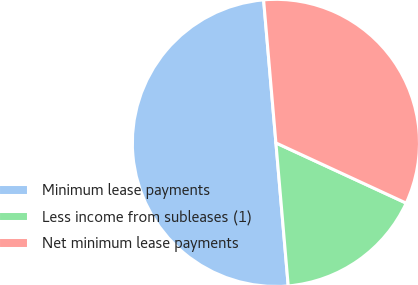Convert chart to OTSL. <chart><loc_0><loc_0><loc_500><loc_500><pie_chart><fcel>Minimum lease payments<fcel>Less income from subleases (1)<fcel>Net minimum lease payments<nl><fcel>50.0%<fcel>16.74%<fcel>33.26%<nl></chart> 